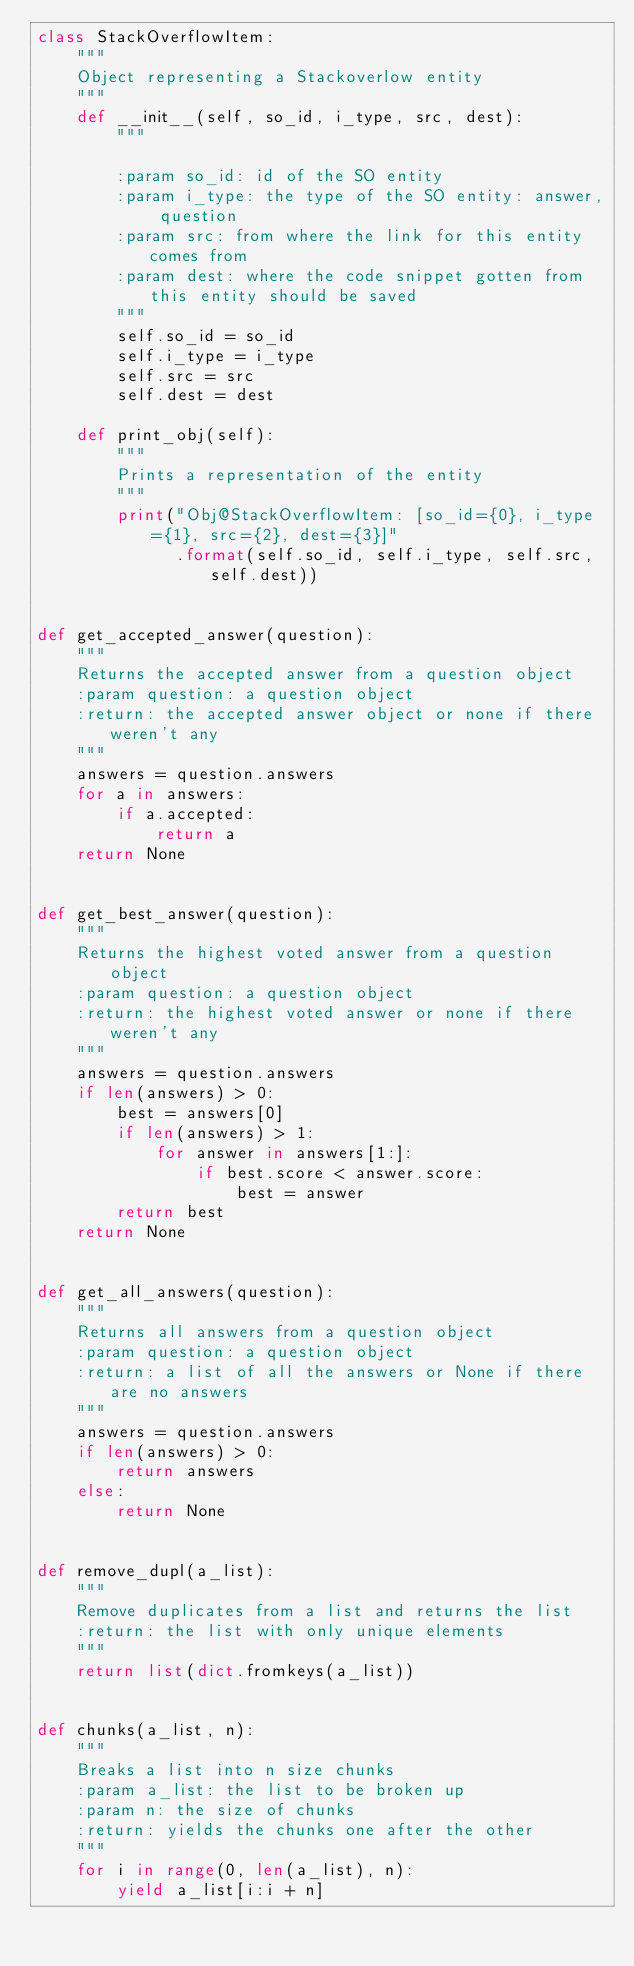Convert code to text. <code><loc_0><loc_0><loc_500><loc_500><_Python_>class StackOverflowItem:
    """
    Object representing a Stackoverlow entity
    """
    def __init__(self, so_id, i_type, src, dest):
        """

        :param so_id: id of the SO entity
        :param i_type: the type of the SO entity: answer, question
        :param src: from where the link for this entity comes from
        :param dest: where the code snippet gotten from this entity should be saved
        """
        self.so_id = so_id
        self.i_type = i_type
        self.src = src
        self.dest = dest

    def print_obj(self):
        """
        Prints a representation of the entity
        """
        print("Obj@StackOverflowItem: [so_id={0}, i_type={1}, src={2}, dest={3}]"
              .format(self.so_id, self.i_type, self.src, self.dest))


def get_accepted_answer(question):
    """
    Returns the accepted answer from a question object
    :param question: a question object
    :return: the accepted answer object or none if there weren't any
    """
    answers = question.answers
    for a in answers:
        if a.accepted:
            return a
    return None


def get_best_answer(question):
    """
    Returns the highest voted answer from a question object
    :param question: a question object
    :return: the highest voted answer or none if there weren't any
    """
    answers = question.answers
    if len(answers) > 0:
        best = answers[0]
        if len(answers) > 1:
            for answer in answers[1:]:
                if best.score < answer.score:
                    best = answer
        return best
    return None


def get_all_answers(question):
    """
    Returns all answers from a question object
    :param question: a question object
    :return: a list of all the answers or None if there are no answers
    """
    answers = question.answers
    if len(answers) > 0:
        return answers
    else:
        return None


def remove_dupl(a_list):
    """
    Remove duplicates from a list and returns the list
    :return: the list with only unique elements
    """
    return list(dict.fromkeys(a_list))


def chunks(a_list, n):
    """
    Breaks a list into n size chunks
    :param a_list: the list to be broken up
    :param n: the size of chunks
    :return: yields the chunks one after the other
    """
    for i in range(0, len(a_list), n):
        yield a_list[i:i + n]
</code> 